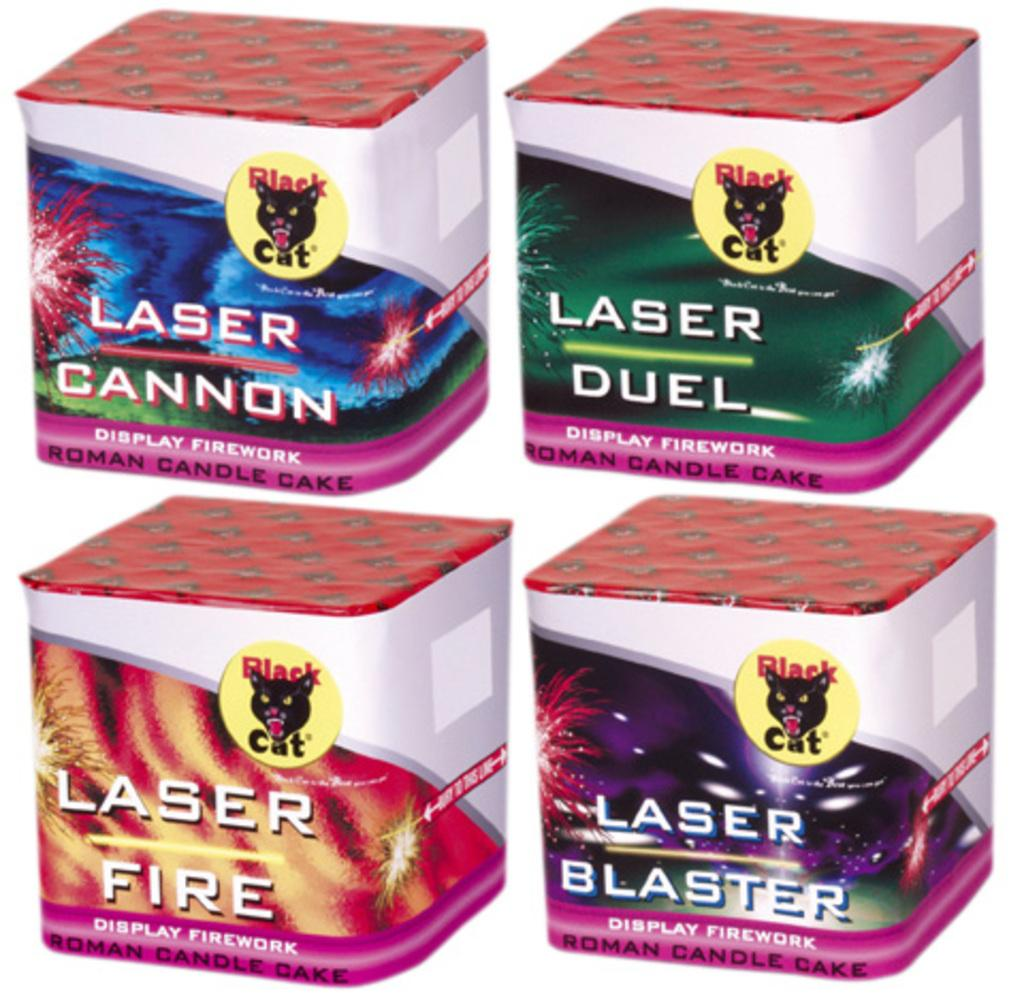<image>
Share a concise interpretation of the image provided. Several different Laser style fireworks are next to each other in their packaging. 